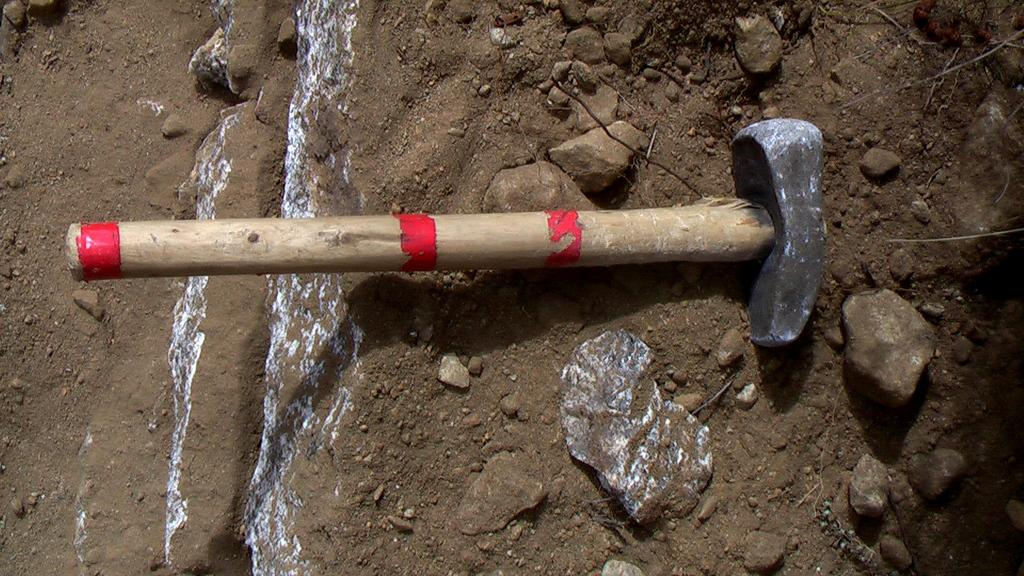What tool is visible in the image? There is a hammer in the image. What type of objects are on the ground in the image? There are stones on the ground in the image. Can you describe the size of the stones in the image? There are small stones in the image. What time of day is depicted in the image? The time of day is not mentioned or depicted in the image. 